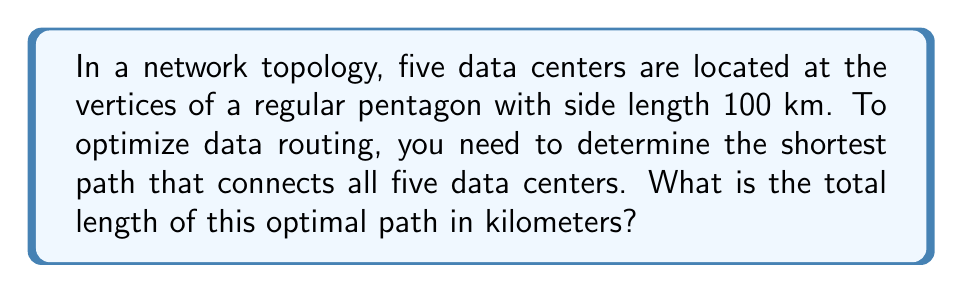Help me with this question. Let's approach this step-by-step:

1) The optimal path that connects all vertices of a regular pentagon is known as the minimum spanning tree of the pentagon.

2) For a regular pentagon, the minimum spanning tree consists of four sides of the pentagon.

3) To prove this, consider the following:
   - Any path connecting all vertices must have at least 4 edges.
   - Using a diagonal instead of a side would result in a longer path.

4) The length of one side of the pentagon is given as 100 km.

5) Therefore, the total length of the optimal path is:

   $$4 * 100 = 400\text{ km}$$

6) We can visualize this as follows:

[asy]
unitsize(1cm);
pair A = (0,0), B = (2,0), C = (2.618,1.902), D = (1,3.078), E = (-0.618,1.902);
draw(A--B--C--D--E--cycle, gray);
draw(A--B--C--D--E, red+1);
label("A", A, SW);
label("B", B, SE);
label("C", C, E);
label("D", D, N);
label("E", E, W);
[/asy]

   The red lines represent the optimal path.
Answer: 400 km 